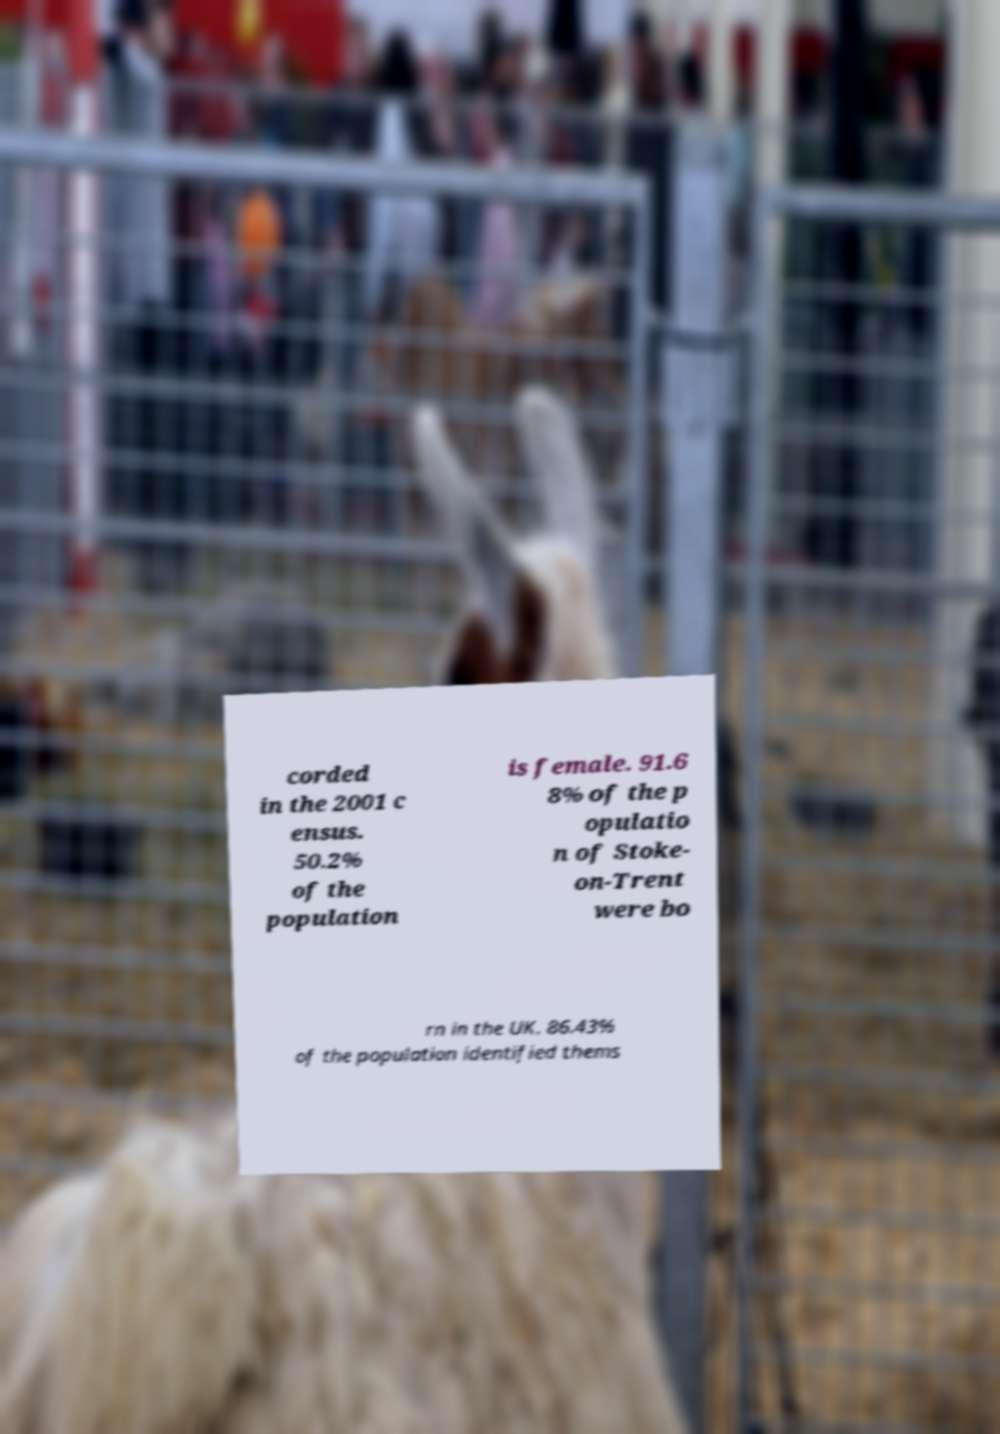For documentation purposes, I need the text within this image transcribed. Could you provide that? corded in the 2001 c ensus. 50.2% of the population is female. 91.6 8% of the p opulatio n of Stoke- on-Trent were bo rn in the UK. 86.43% of the population identified thems 